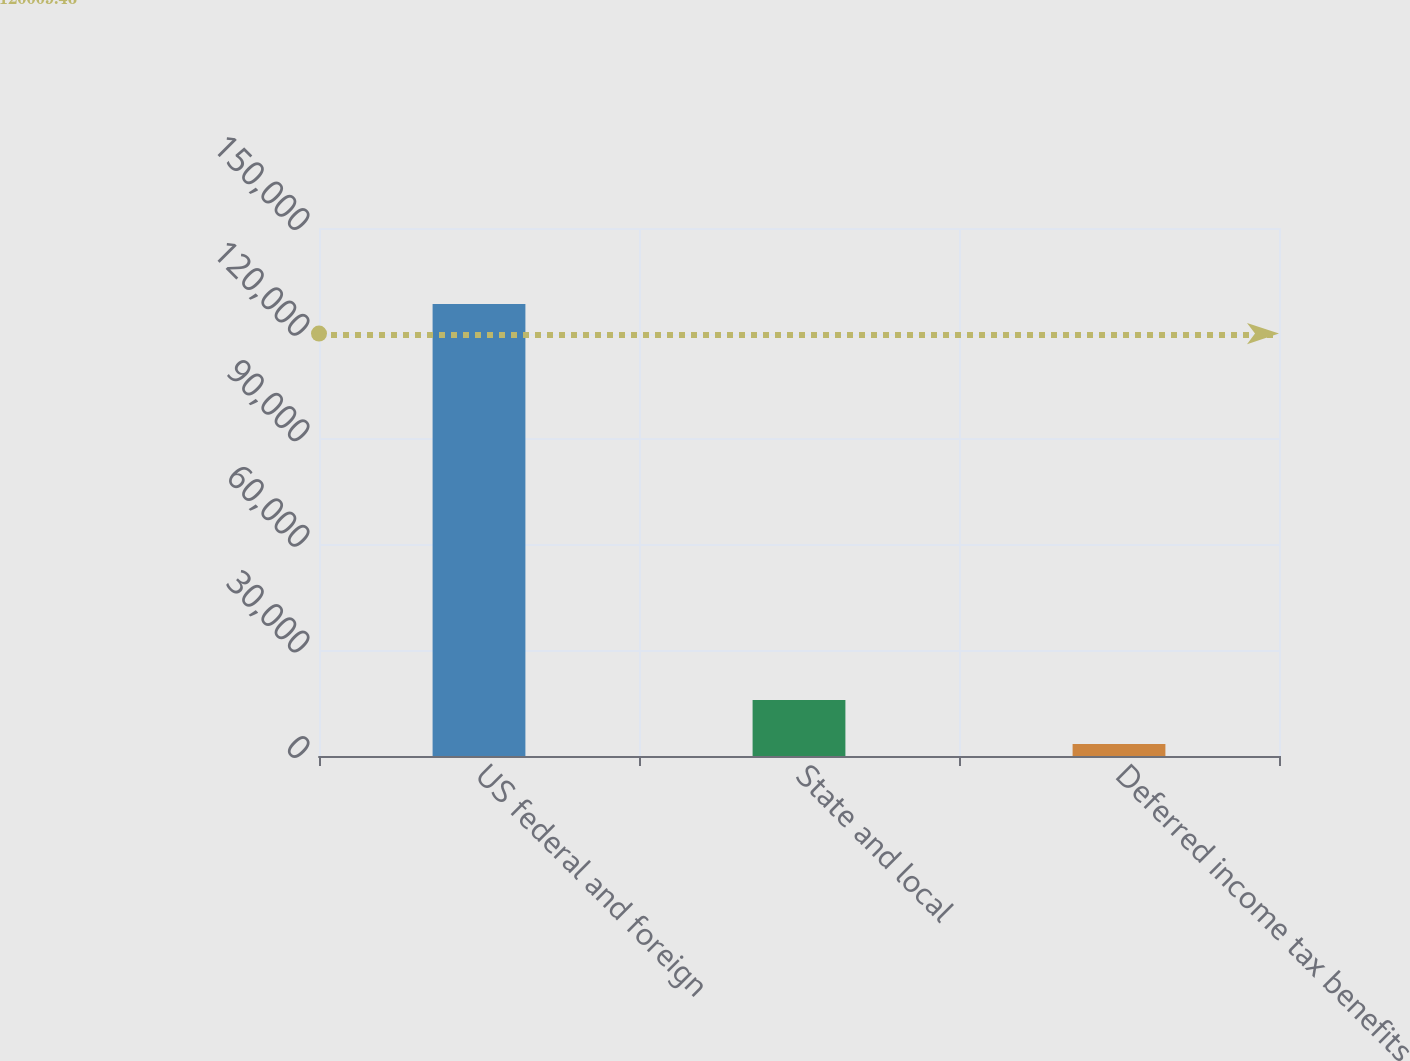<chart> <loc_0><loc_0><loc_500><loc_500><bar_chart><fcel>US federal and foreign<fcel>State and local<fcel>Deferred income tax benefits<nl><fcel>128380<fcel>15894.4<fcel>3396<nl></chart> 